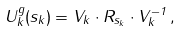<formula> <loc_0><loc_0><loc_500><loc_500>U _ { k } ^ { g } ( s _ { k } ) = V _ { k } \cdot R _ { s _ { k } } \cdot V _ { k } ^ { - 1 } \, ,</formula> 